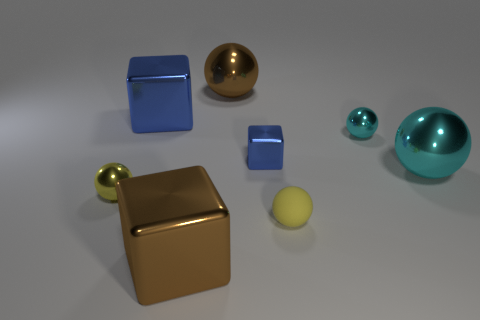Subtract 3 balls. How many balls are left? 2 Add 1 big yellow rubber cubes. How many objects exist? 9 Subtract all cyan balls. How many balls are left? 3 Subtract all matte balls. How many balls are left? 4 Subtract all red spheres. Subtract all purple cylinders. How many spheres are left? 5 Subtract all spheres. How many objects are left? 3 Subtract 0 purple cylinders. How many objects are left? 8 Subtract all tiny blue shiny objects. Subtract all small blocks. How many objects are left? 6 Add 5 big things. How many big things are left? 9 Add 7 big cyan objects. How many big cyan objects exist? 8 